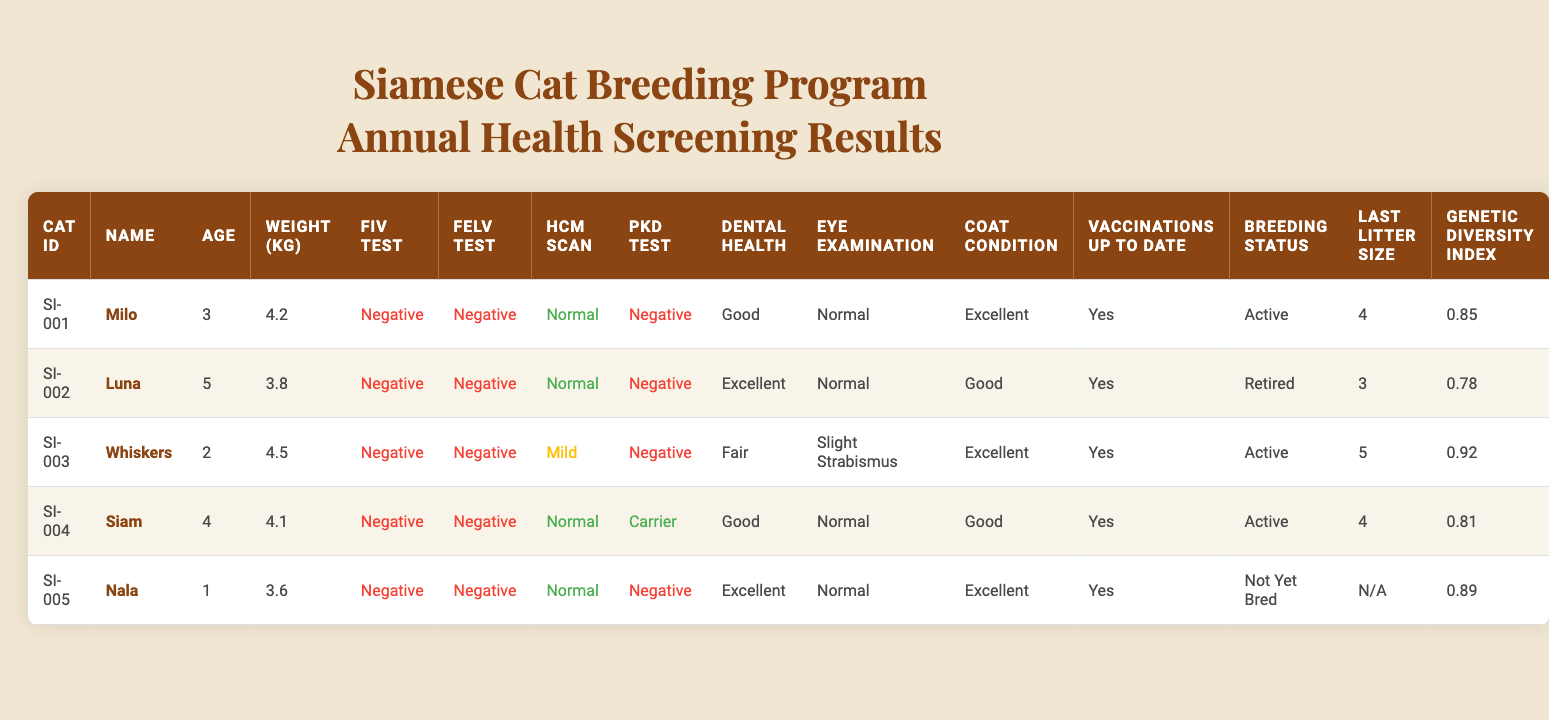What is the weight of Whiskers? By locating Whiskers' row in the table, the 'Weight (kg)' column shows that Whiskers weighs 4.5 kg.
Answer: 4.5 kg How many cats have a Normal HCM Scan result? Scanning through the 'HCM Scan' column, there are four entries marked 'Normal' (Milo, Luna, Siam, Nala) out of five cats in total.
Answer: 4 Is Nala up to date with vaccinations? Examining Nala's row in the 'Vaccinations Up To Date' column, it indicates 'Yes', confirming she is up to date with vaccinations.
Answer: Yes What is the average age of the cats in the program? The ages of the cats are 3, 5, 2, 4, and 1. Summing these gives 15 and dividing by the number of cats (5) results in an average age of 3.
Answer: 3 Which cat has the highest Genetic Diversity Index? By comparing the 'Genetic Diversity Index' values (0.85, 0.78, 0.92, 0.81, 0.89), Whiskers has the highest value at 0.92.
Answer: Whiskers How many cats are still active in breeding? Checking the 'Breeding Status' column, there are three entries marked 'Active' (Milo, Whiskers, Siam).
Answer: 3 What condition did Luna show during the eye examination? Looking at Luna's row, the 'Eye Examination' column states 'Normal', indicating she had no issues.
Answer: Normal Is there a cat that is a PKD Carrier? In the 'PKD Test' column, only Siam is marked as 'Carrier'. Therefore, yes, there is a PKD Carrier.
Answer: Yes What is the litter size of the last litter for Milo? In the 'Last Litter Size' column under Milo, the entry shows the value as 4, meaning Milo's last litter had 4 kittens.
Answer: 4 Which cat has both Excellent Dental Health and Coat Condition? Reviewing the 'Dental Health' and 'Coat Condition' columns, we see Nala has 'Excellent' in both categories.
Answer: Nala If we consider the average weight of all cats, what is it? The total weight of the cats (4.2 + 3.8 + 4.5 + 4.1 + 3.6) is 20.2 kg. Divided by 5 gives an average weight of 4.04 kg.
Answer: 4.04 kg Which cat is the youngest and what is its age? The youngest cat is Nala, whose age is listed as 1 year in the 'Age' column.
Answer: 1 year Which cat has the worst dental health condition? Parsing through the 'Dental Health' column, Whiskers is the only one with the condition marked as 'Fair', making it the worst.
Answer: Whiskers What is the total number of cats tested for FeLV? All five cats are present in the table, and they all have entries under the 'FeLV Test' column. Hence, the total is 5.
Answer: 5 Are all cats showing Negative results for FIV? The 'FIV Test' column indicates all entries are 'Negative', confirming that all cats tested negative for this condition.
Answer: Yes 